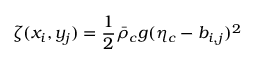Convert formula to latex. <formula><loc_0><loc_0><loc_500><loc_500>\zeta ( x _ { i } , y _ { j } ) = \frac { 1 } { 2 } \bar { \rho } _ { c } g ( \eta _ { c } - b _ { i , j } ) ^ { 2 }</formula> 